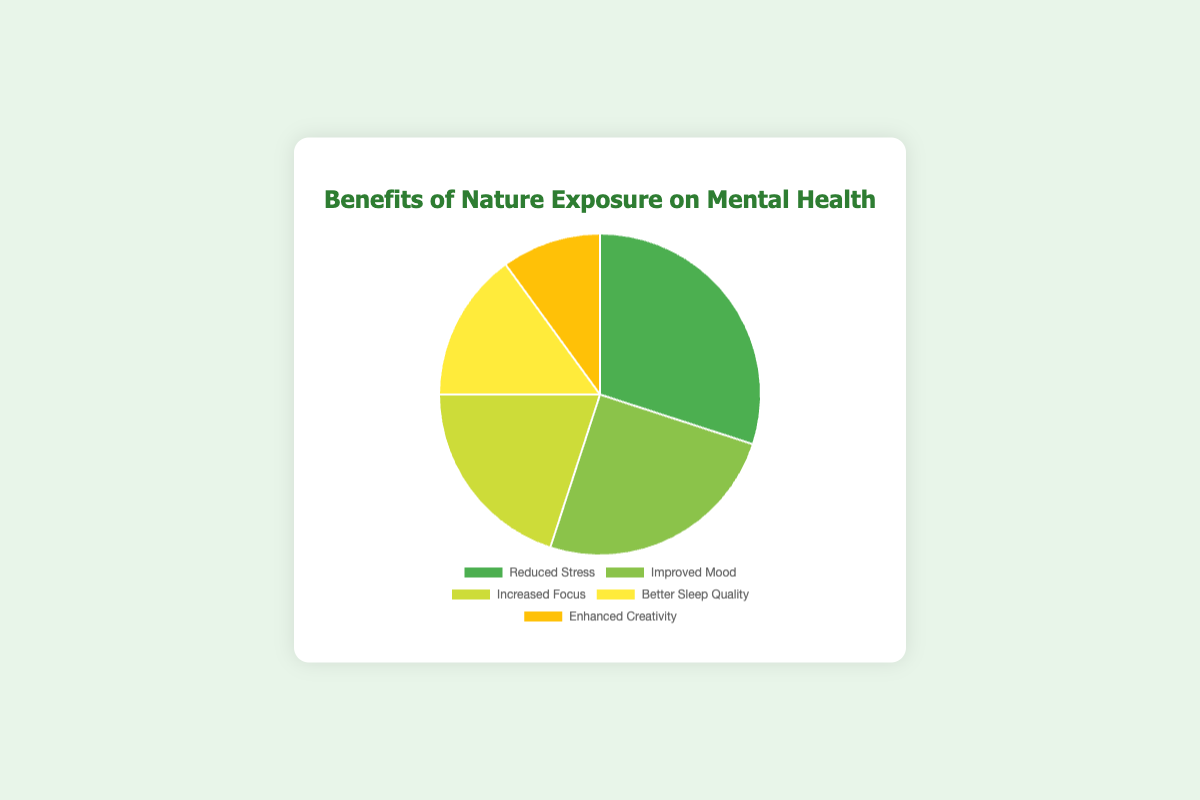Which benefit of nature exposure has the highest percentage? By observing the pie chart, identify the segment with the largest size. In this chart, the "Reduced Stress" segment is the largest.
Answer: Reduced Stress Which benefit is represented by the smallest segment of the pie chart? Look at the pie chart and find the smallest segment. The smallest segment represents "Enhanced Creativity."
Answer: Enhanced Creativity What is the total percentage for Improved Mood and Better Sleep Quality combined? Locate the percentage values for "Improved Mood" and "Better Sleep Quality," which are 25% and 15% respectively. Summing these, 25% + 15% = 40%.
Answer: 40% How does the percentage of Increased Focus compare to Enhanced Creativity? Compare the percentage values of "Increased Focus" (20%) and "Enhanced Creativity" (10%). Increased Focus has a higher percentage than Enhanced Creativity.
Answer: Increased Focus > Enhanced Creativity Which two benefits have a combined percentage equal to the percentage of Reduced Stress? The percentage of "Reduced Stress" is 30%. By checking combinations, "Improved Mood" (25%) and "Enhanced Creativity" (10%) are not equal; "Improved Mood" (25%) and "Better Sleep Quality" (15%) are not equal; "Increased Focus" (20%) and "Better Sleep Quality" (15%) are not equal; Here, no two benefits combined equal 30%.
Answer: None What is the average percentage of the listed benefits? Sum the percentages of all categories: 30% (Reduced Stress) + 25% (Improved Mood) + 20% (Increased Focus) + 15% (Better Sleep Quality) + 10% (Enhanced Creativity) = 100%. Then divide by the number of categories: 100% / 5 = 20%.
Answer: 20% If the percentages of Reduced Stress and Improved Mood were swapped, which benefit would then have the highest percentage? If the percentages are swapped, "Reduced Stress" would have 25% and "Improved Mood" would have 30%. "Improved Mood" would then have the highest percentage.
Answer: Improved Mood Which color represents the benefit with the second highest percentage? Identify the segment with the second highest percentage: "Improved Mood" (25%). The color for "Improved Mood" is visually identifiable as the specific shade of green used in the chart.
Answer: Light Green 